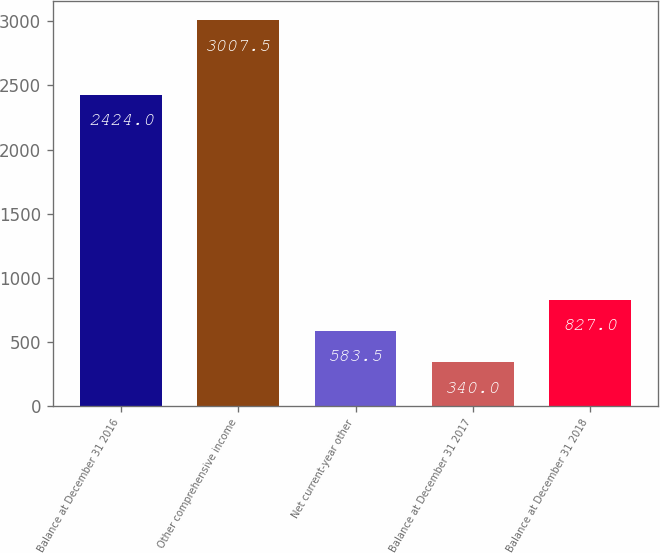Convert chart. <chart><loc_0><loc_0><loc_500><loc_500><bar_chart><fcel>Balance at December 31 2016<fcel>Other comprehensive income<fcel>Net current-year other<fcel>Balance at December 31 2017<fcel>Balance at December 31 2018<nl><fcel>2424<fcel>3007.5<fcel>583.5<fcel>340<fcel>827<nl></chart> 